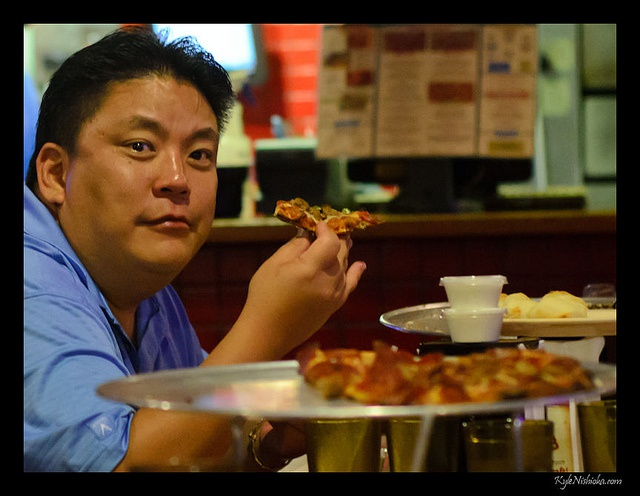Describe the objects in this image and their specific colors. I can see people in black, brown, maroon, and gray tones, pizza in black, brown, and maroon tones, cup in black, olive, and gray tones, cup in black, olive, and maroon tones, and cup in black, olive, and gray tones in this image. 